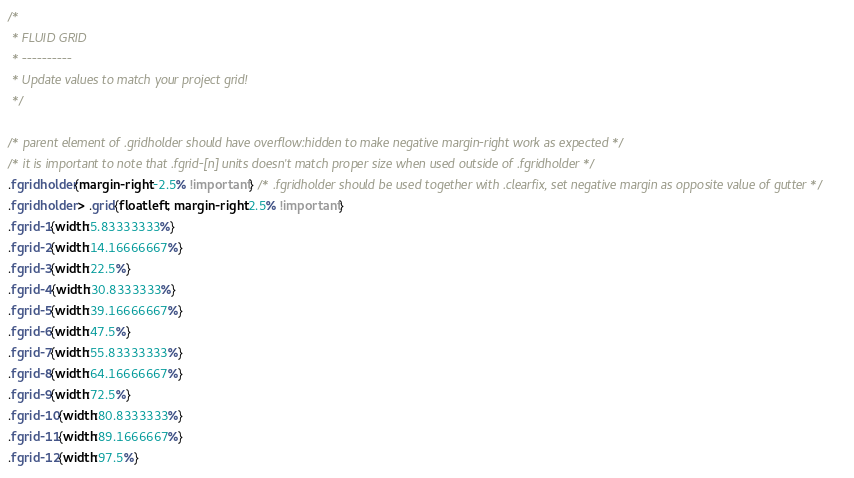Convert code to text. <code><loc_0><loc_0><loc_500><loc_500><_CSS_>/*
 * FLUID GRID
 * ----------
 * Update values to match your project grid!
 */

/* parent element of .gridholder should have overflow:hidden to make negative margin-right work as expected */
/* it is important to note that .fgrid-[n] units doesn't match proper size when used outside of .fgridholder */
.fgridholder{margin-right:-2.5% !important} /* .fgridholder should be used together with .clearfix, set negative margin as opposite value of gutter */
.fgridholder > .grid{float:left; margin-right:2.5% !important}
.fgrid-1{width:5.83333333%}
.fgrid-2{width:14.16666667%}
.fgrid-3{width:22.5%}
.fgrid-4{width:30.8333333%}
.fgrid-5{width:39.16666667%}
.fgrid-6{width:47.5%}
.fgrid-7{width:55.83333333%}
.fgrid-8{width:64.16666667%}
.fgrid-9{width:72.5%}
.fgrid-10{width:80.8333333%}
.fgrid-11{width:89.1666667%}
.fgrid-12{width:97.5%}

</code> 